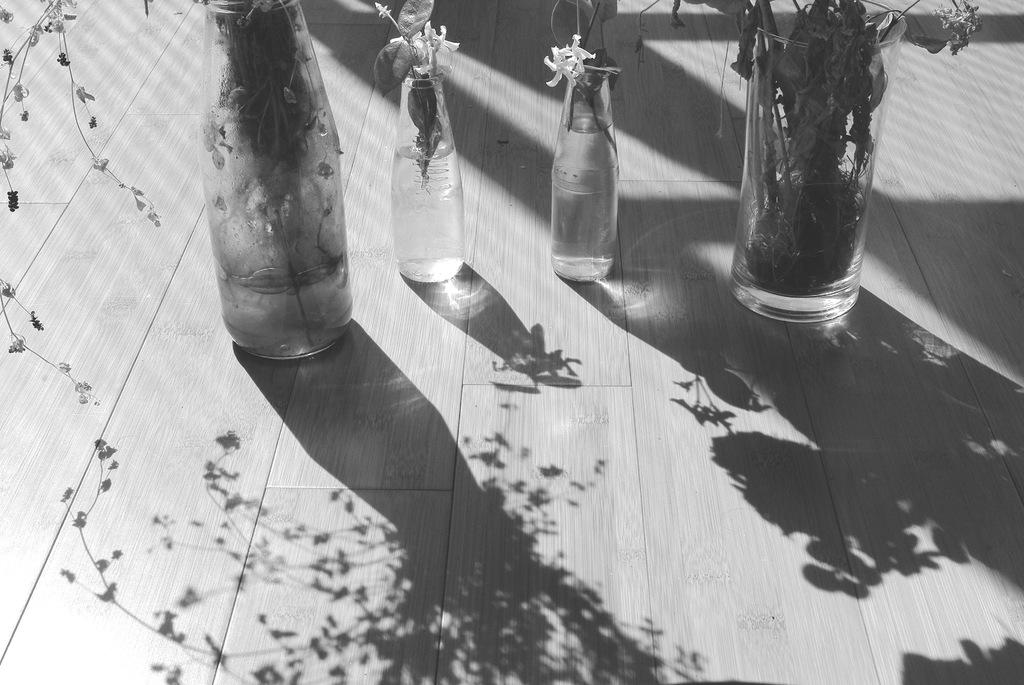How many bottles are visible in the image? There are four bottles in the image. Where are the bottles located in the image? The bottles are on the floor. What type of vegetable is growing out of the bottles in the image? There are no vegetables present in the image; it only features four bottles on the floor. 